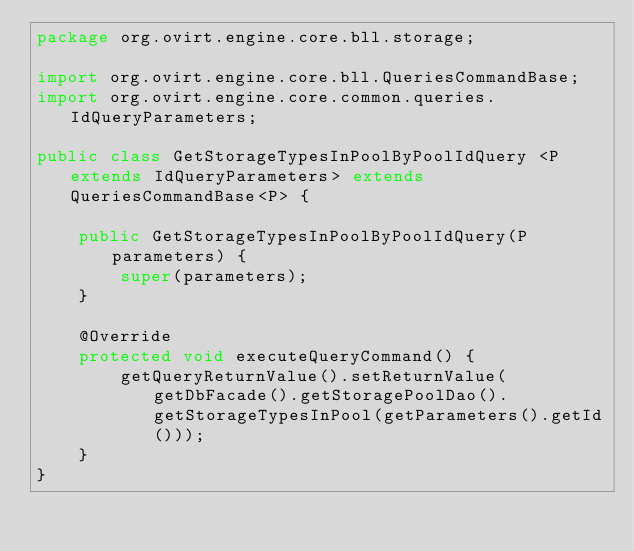<code> <loc_0><loc_0><loc_500><loc_500><_Java_>package org.ovirt.engine.core.bll.storage;

import org.ovirt.engine.core.bll.QueriesCommandBase;
import org.ovirt.engine.core.common.queries.IdQueryParameters;

public class GetStorageTypesInPoolByPoolIdQuery <P extends IdQueryParameters> extends QueriesCommandBase<P> {

    public GetStorageTypesInPoolByPoolIdQuery(P parameters) {
        super(parameters);
    }

    @Override
    protected void executeQueryCommand() {
        getQueryReturnValue().setReturnValue(getDbFacade().getStoragePoolDao().getStorageTypesInPool(getParameters().getId()));
    }
}
</code> 